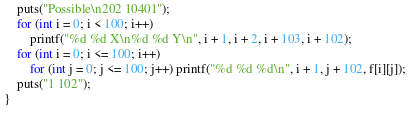<code> <loc_0><loc_0><loc_500><loc_500><_C++_>	puts("Possible\n202 10401");
	for (int i = 0; i < 100; i++)
		printf("%d %d X\n%d %d Y\n", i + 1, i + 2, i + 103, i + 102);
	for (int i = 0; i <= 100; i++)
		for (int j = 0; j <= 100; j++) printf("%d %d %d\n", i + 1, j + 102, f[i][j]);
	puts("1 102");
}</code> 